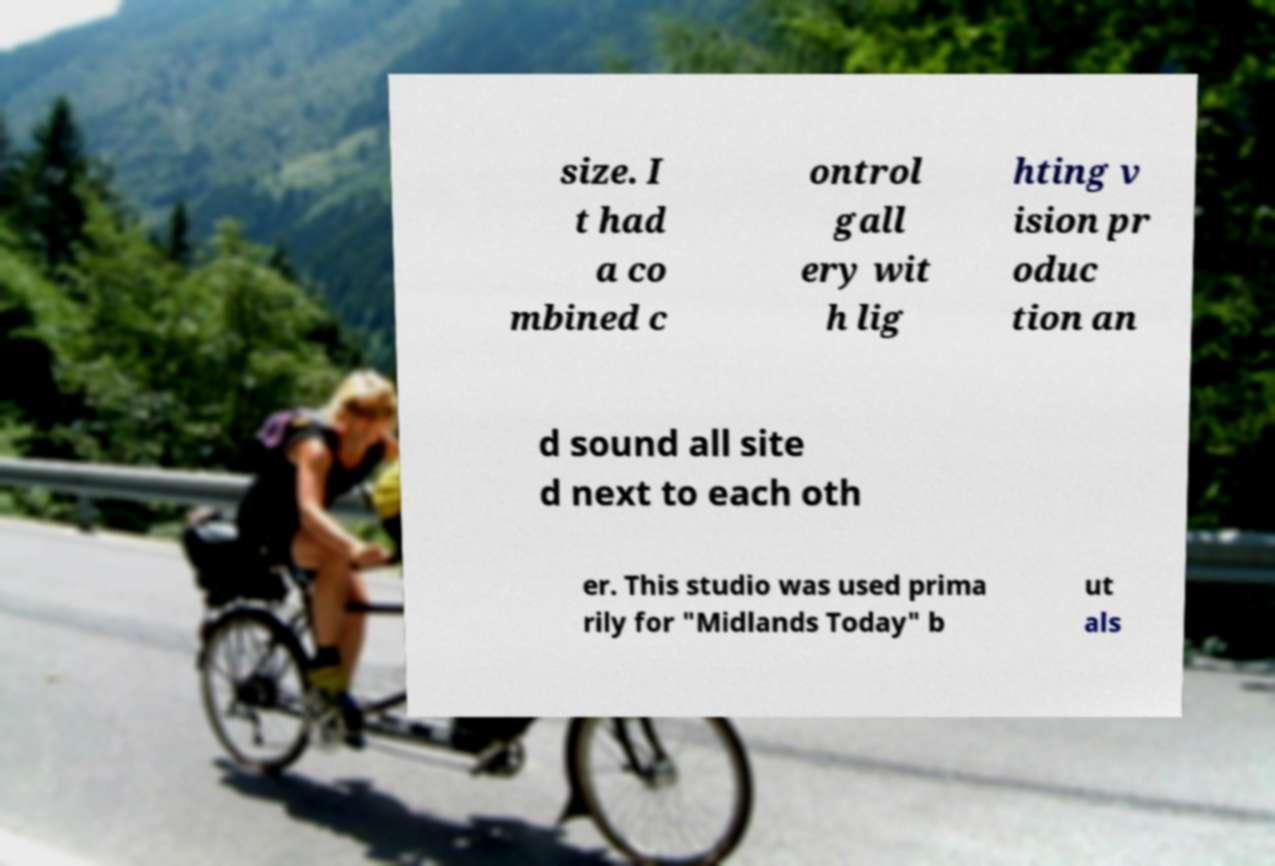There's text embedded in this image that I need extracted. Can you transcribe it verbatim? size. I t had a co mbined c ontrol gall ery wit h lig hting v ision pr oduc tion an d sound all site d next to each oth er. This studio was used prima rily for "Midlands Today" b ut als 